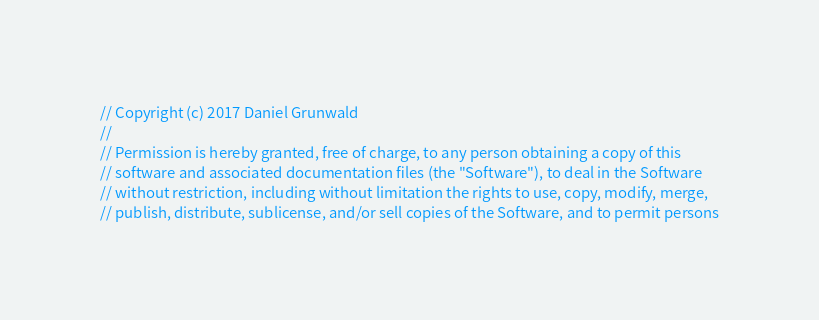<code> <loc_0><loc_0><loc_500><loc_500><_Rust_>// Copyright (c) 2017 Daniel Grunwald
//
// Permission is hereby granted, free of charge, to any person obtaining a copy of this
// software and associated documentation files (the "Software"), to deal in the Software
// without restriction, including without limitation the rights to use, copy, modify, merge,
// publish, distribute, sublicense, and/or sell copies of the Software, and to permit persons</code> 